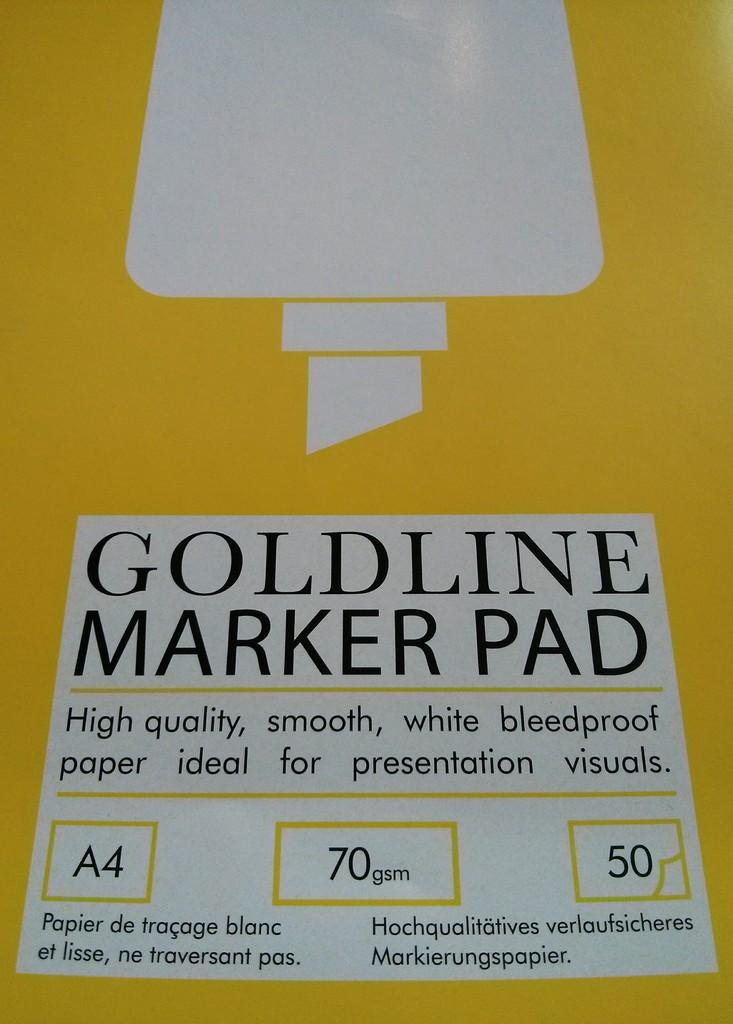<image>
Provide a brief description of the given image. Yellow board that says "Goldline Marker Pad" near the middle. 